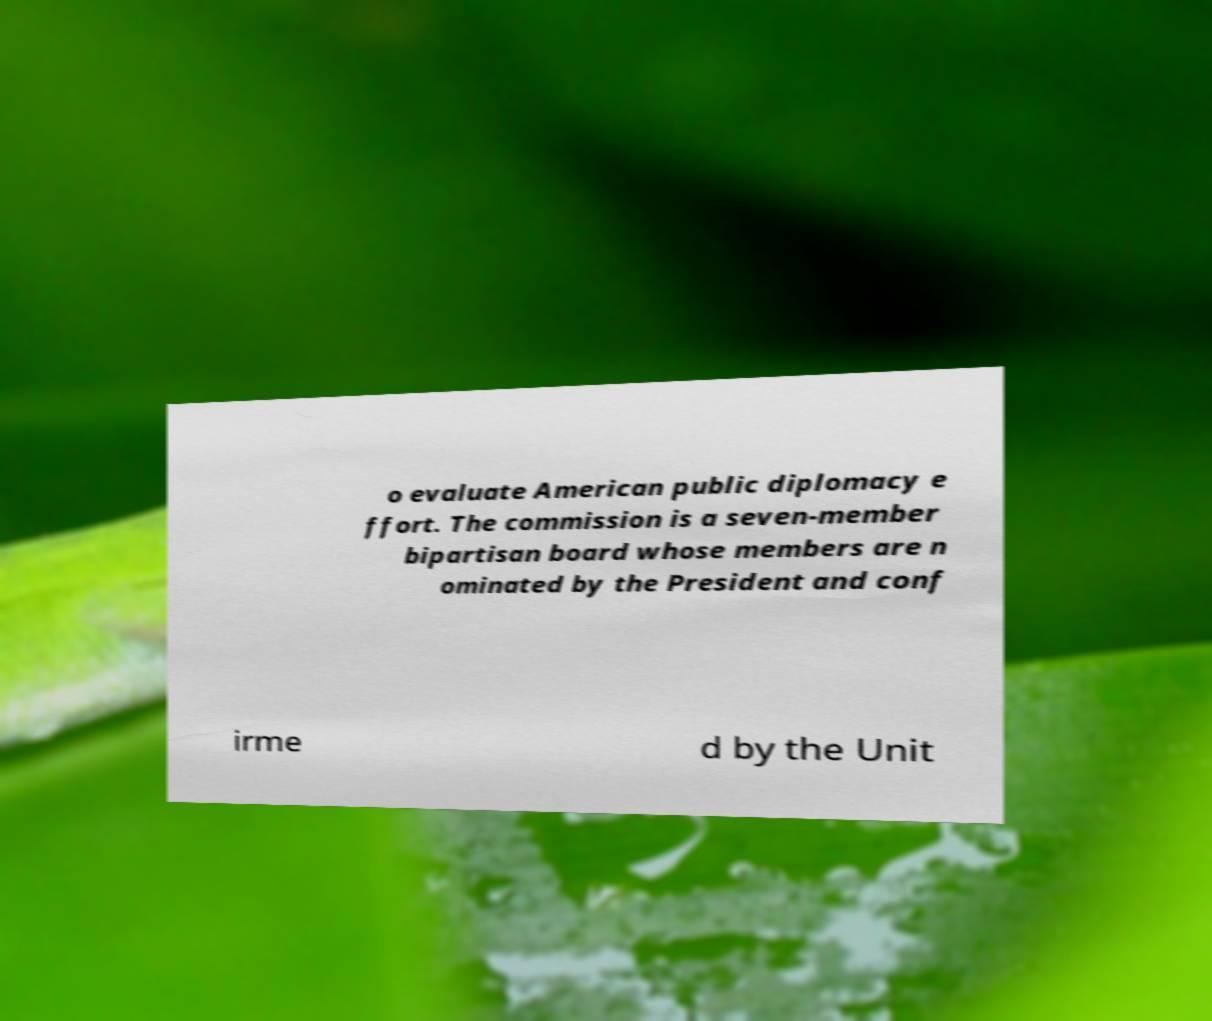Please read and relay the text visible in this image. What does it say? o evaluate American public diplomacy e ffort. The commission is a seven-member bipartisan board whose members are n ominated by the President and conf irme d by the Unit 